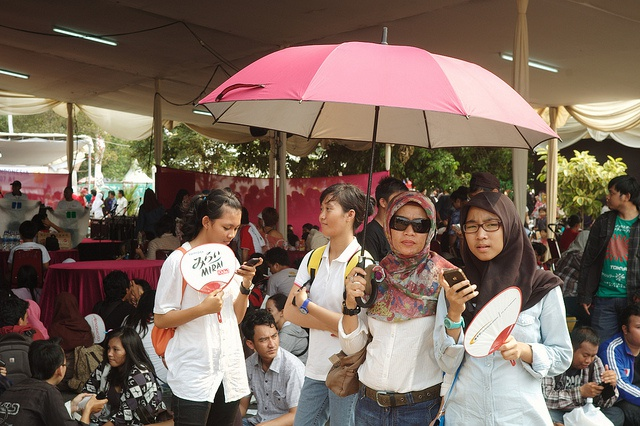Describe the objects in this image and their specific colors. I can see umbrella in black, lightpink, tan, and pink tones, people in black, lightgray, darkgray, and maroon tones, people in black, white, gray, and tan tones, people in black, lightgray, brown, and darkgray tones, and people in black, lightgray, gray, and tan tones in this image. 